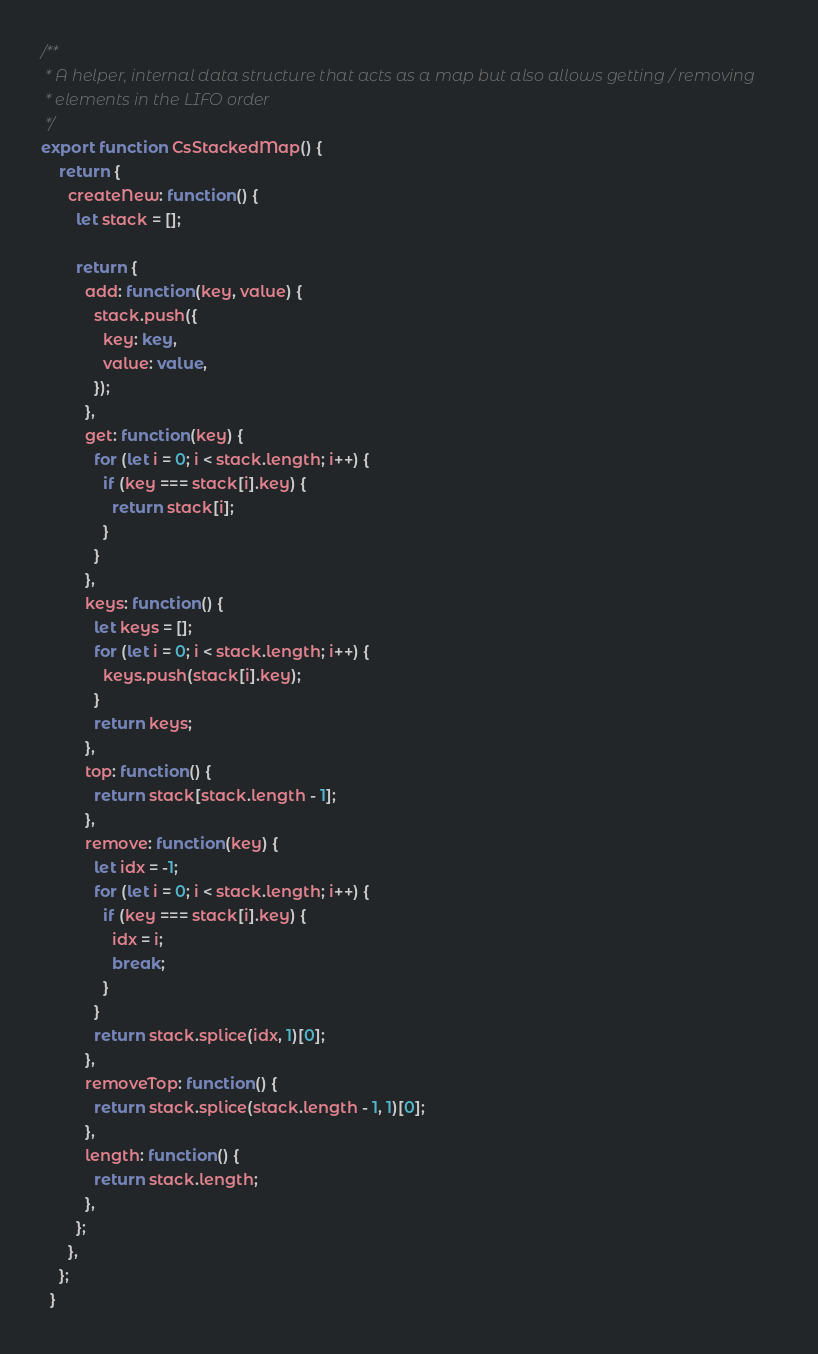<code> <loc_0><loc_0><loc_500><loc_500><_TypeScript_>/**
 * A helper, internal data structure that acts as a map but also allows getting / removing
 * elements in the LIFO order
 */
export function CsStackedMap() {
    return {
      createNew: function() {
        let stack = [];

        return {
          add: function(key, value) {
            stack.push({
              key: key,
              value: value,
            });
          },
          get: function(key) {
            for (let i = 0; i < stack.length; i++) {
              if (key === stack[i].key) {
                return stack[i];
              }
            }
          },
          keys: function() {
            let keys = [];
            for (let i = 0; i < stack.length; i++) {
              keys.push(stack[i].key);
            }
            return keys;
          },
          top: function() {
            return stack[stack.length - 1];
          },
          remove: function(key) {
            let idx = -1;
            for (let i = 0; i < stack.length; i++) {
              if (key === stack[i].key) {
                idx = i;
                break;
              }
            }
            return stack.splice(idx, 1)[0];
          },
          removeTop: function() {
            return stack.splice(stack.length - 1, 1)[0];
          },
          length: function() {
            return stack.length;
          },
        };
      },
    };
  }
</code> 